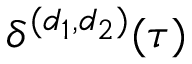Convert formula to latex. <formula><loc_0><loc_0><loc_500><loc_500>\delta ^ { ( d _ { 1 } , d _ { 2 } ) } ( \tau )</formula> 